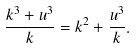<formula> <loc_0><loc_0><loc_500><loc_500>\frac { k ^ { 3 } + u ^ { 3 } } { k } = k ^ { 2 } + \frac { u ^ { 3 } } { k } .</formula> 